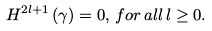<formula> <loc_0><loc_0><loc_500><loc_500>H ^ { 2 l + 1 } \left ( \gamma \right ) = 0 , \, f o r \, a l l \, l \geq 0 .</formula> 